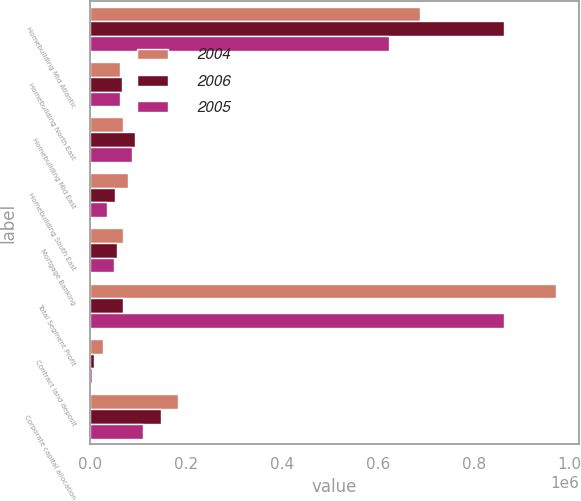Convert chart. <chart><loc_0><loc_0><loc_500><loc_500><stacked_bar_chart><ecel><fcel>Homebuilding Mid Atlantic<fcel>Homebuilding North East<fcel>Homebuilding Mid East<fcel>Homebuilding South East<fcel>Mortgage Banking<fcel>Total Segment Profit<fcel>Contract land deposit<fcel>Corporate capital allocation<nl><fcel>2004<fcel>687904<fcel>64246<fcel>69911<fcel>79948<fcel>68753<fcel>970762<fcel>27717<fcel>184908<nl><fcel>2006<fcel>863210<fcel>66944<fcel>95190<fcel>52199<fcel>57739<fcel>69911<fcel>9950<fcel>149247<nl><fcel>2005<fcel>623040<fcel>64130<fcel>87272<fcel>36958<fcel>50862<fcel>862262<fcel>6000<fcel>110769<nl></chart> 